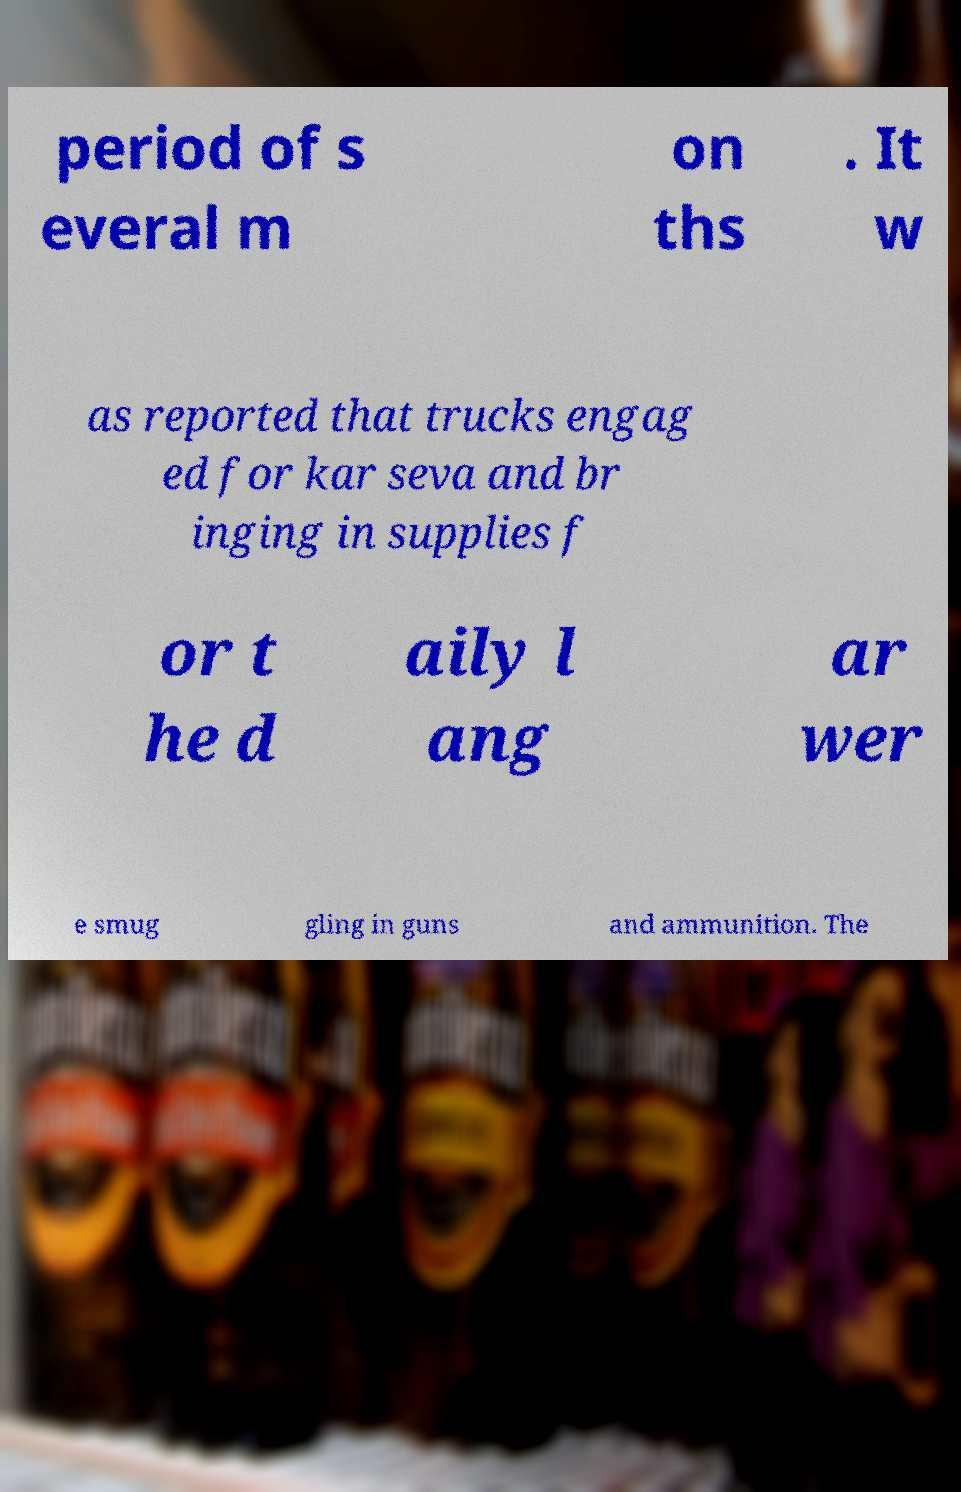Can you read and provide the text displayed in the image?This photo seems to have some interesting text. Can you extract and type it out for me? period of s everal m on ths . It w as reported that trucks engag ed for kar seva and br inging in supplies f or t he d aily l ang ar wer e smug gling in guns and ammunition. The 